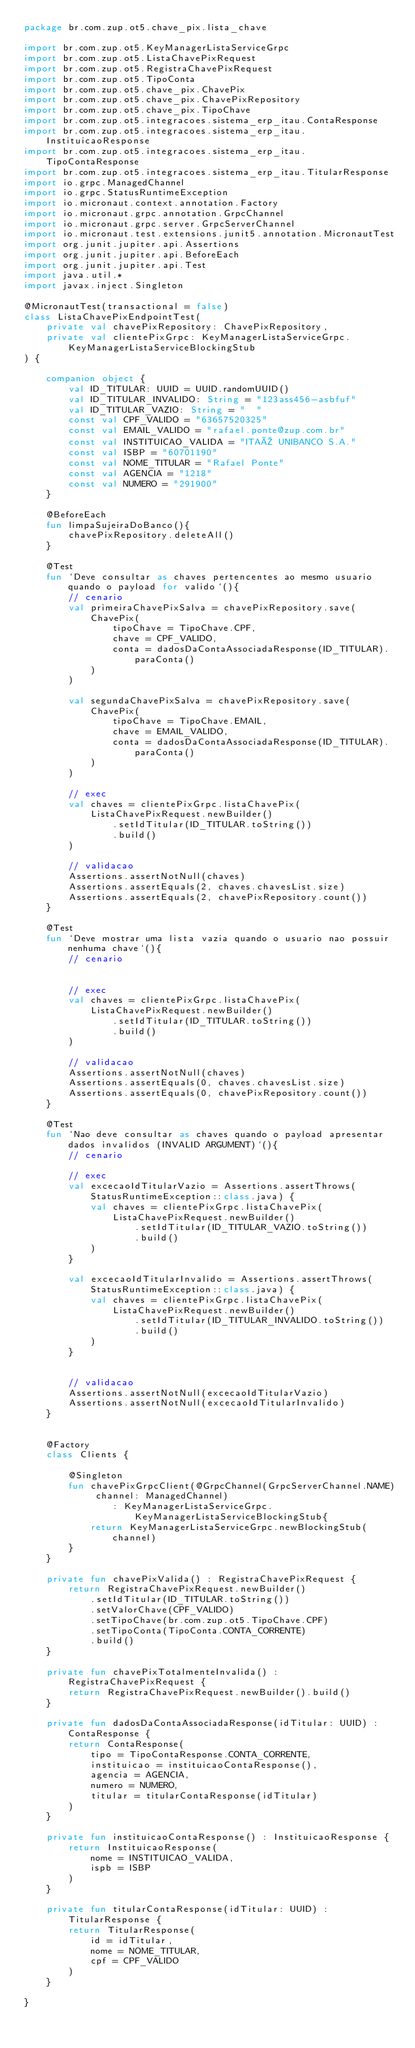Convert code to text. <code><loc_0><loc_0><loc_500><loc_500><_Kotlin_>package br.com.zup.ot5.chave_pix.lista_chave

import br.com.zup.ot5.KeyManagerListaServiceGrpc
import br.com.zup.ot5.ListaChavePixRequest
import br.com.zup.ot5.RegistraChavePixRequest
import br.com.zup.ot5.TipoConta
import br.com.zup.ot5.chave_pix.ChavePix
import br.com.zup.ot5.chave_pix.ChavePixRepository
import br.com.zup.ot5.chave_pix.TipoChave
import br.com.zup.ot5.integracoes.sistema_erp_itau.ContaResponse
import br.com.zup.ot5.integracoes.sistema_erp_itau.InstituicaoResponse
import br.com.zup.ot5.integracoes.sistema_erp_itau.TipoContaResponse
import br.com.zup.ot5.integracoes.sistema_erp_itau.TitularResponse
import io.grpc.ManagedChannel
import io.grpc.StatusRuntimeException
import io.micronaut.context.annotation.Factory
import io.micronaut.grpc.annotation.GrpcChannel
import io.micronaut.grpc.server.GrpcServerChannel
import io.micronaut.test.extensions.junit5.annotation.MicronautTest
import org.junit.jupiter.api.Assertions
import org.junit.jupiter.api.BeforeEach
import org.junit.jupiter.api.Test
import java.util.*
import javax.inject.Singleton

@MicronautTest(transactional = false)
class ListaChavePixEndpointTest(
    private val chavePixRepository: ChavePixRepository,
    private val clientePixGrpc: KeyManagerListaServiceGrpc.KeyManagerListaServiceBlockingStub
) {

    companion object {
        val ID_TITULAR: UUID = UUID.randomUUID()
        val ID_TITULAR_INVALIDO: String = "123ass456-asbfuf"
        val ID_TITULAR_VAZIO: String = "  "
        const val CPF_VALIDO = "63657520325"
        const val EMAIL_VALIDO = "rafael.ponte@zup.com.br"
        const val INSTITUICAO_VALIDA = "ITAÚ UNIBANCO S.A."
        const val ISBP = "60701190"
        const val NOME_TITULAR = "Rafael Ponte"
        const val AGENCIA = "1218"
        const val NUMERO = "291900"
    }

    @BeforeEach
    fun limpaSujeiraDoBanco(){
        chavePixRepository.deleteAll()
    }

    @Test
    fun `Deve consultar as chaves pertencentes ao mesmo usuario quando o payload for valido`(){
        // cenario
        val primeiraChavePixSalva = chavePixRepository.save(
            ChavePix(
                tipoChave = TipoChave.CPF,
                chave = CPF_VALIDO,
                conta = dadosDaContaAssociadaResponse(ID_TITULAR).paraConta()
            )
        )

        val segundaChavePixSalva = chavePixRepository.save(
            ChavePix(
                tipoChave = TipoChave.EMAIL,
                chave = EMAIL_VALIDO,
                conta = dadosDaContaAssociadaResponse(ID_TITULAR).paraConta()
            )
        )

        // exec
        val chaves = clientePixGrpc.listaChavePix(
            ListaChavePixRequest.newBuilder()
                .setIdTitular(ID_TITULAR.toString())
                .build()
        )

        // validacao
        Assertions.assertNotNull(chaves)
        Assertions.assertEquals(2, chaves.chavesList.size)
        Assertions.assertEquals(2, chavePixRepository.count())
    }

    @Test
    fun `Deve mostrar uma lista vazia quando o usuario nao possuir nenhuma chave`(){
        // cenario


        // exec
        val chaves = clientePixGrpc.listaChavePix(
            ListaChavePixRequest.newBuilder()
                .setIdTitular(ID_TITULAR.toString())
                .build()
        )

        // validacao
        Assertions.assertNotNull(chaves)
        Assertions.assertEquals(0, chaves.chavesList.size)
        Assertions.assertEquals(0, chavePixRepository.count())
    }

    @Test
    fun `Nao deve consultar as chaves quando o payload apresentar dados invalidos (INVALID ARGUMENT)`(){
        // cenario

        // exec
        val excecaoIdTitularVazio = Assertions.assertThrows(StatusRuntimeException::class.java) {
            val chaves = clientePixGrpc.listaChavePix(
                ListaChavePixRequest.newBuilder()
                    .setIdTitular(ID_TITULAR_VAZIO.toString())
                    .build()
            )
        }

        val excecaoIdTitularInvalido = Assertions.assertThrows(StatusRuntimeException::class.java) {
            val chaves = clientePixGrpc.listaChavePix(
                ListaChavePixRequest.newBuilder()
                    .setIdTitular(ID_TITULAR_INVALIDO.toString())
                    .build()
            )
        }


        // validacao
        Assertions.assertNotNull(excecaoIdTitularVazio)
        Assertions.assertNotNull(excecaoIdTitularInvalido)
    }


    @Factory
    class Clients {

        @Singleton
        fun chavePixGrpcClient(@GrpcChannel(GrpcServerChannel.NAME) channel: ManagedChannel)
                : KeyManagerListaServiceGrpc.KeyManagerListaServiceBlockingStub{
            return KeyManagerListaServiceGrpc.newBlockingStub(channel)
        }
    }

    private fun chavePixValida() : RegistraChavePixRequest {
        return RegistraChavePixRequest.newBuilder()
            .setIdTitular(ID_TITULAR.toString())
            .setValorChave(CPF_VALIDO)
            .setTipoChave(br.com.zup.ot5.TipoChave.CPF)
            .setTipoConta(TipoConta.CONTA_CORRENTE)
            .build()
    }

    private fun chavePixTotalmenteInvalida() : RegistraChavePixRequest {
        return RegistraChavePixRequest.newBuilder().build()
    }

    private fun dadosDaContaAssociadaResponse(idTitular: UUID) : ContaResponse {
        return ContaResponse(
            tipo = TipoContaResponse.CONTA_CORRENTE,
            instituicao = instituicaoContaResponse(),
            agencia = AGENCIA,
            numero = NUMERO,
            titular = titularContaResponse(idTitular)
        )
    }

    private fun instituicaoContaResponse() : InstituicaoResponse {
        return InstituicaoResponse(
            nome = INSTITUICAO_VALIDA,
            ispb = ISBP
        )
    }

    private fun titularContaResponse(idTitular: UUID) : TitularResponse {
        return TitularResponse(
            id = idTitular,
            nome = NOME_TITULAR,
            cpf = CPF_VALIDO
        )
    }

}</code> 